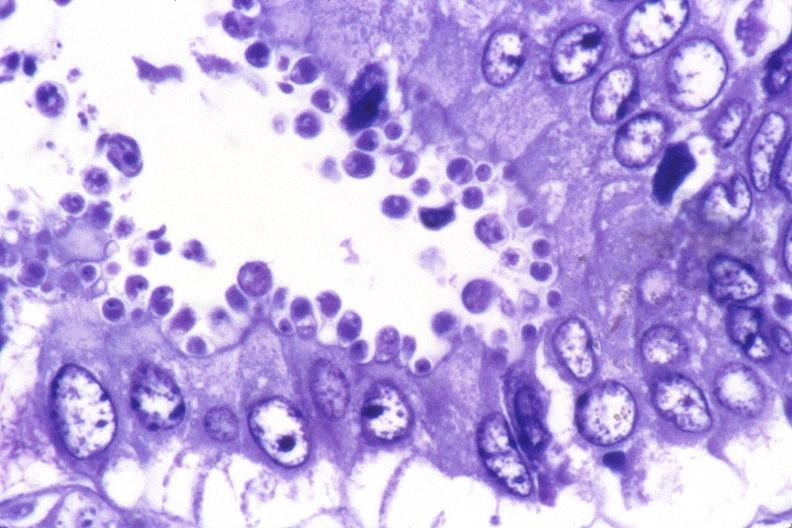does acrocyanosis show colon, cryptosporidia?
Answer the question using a single word or phrase. No 